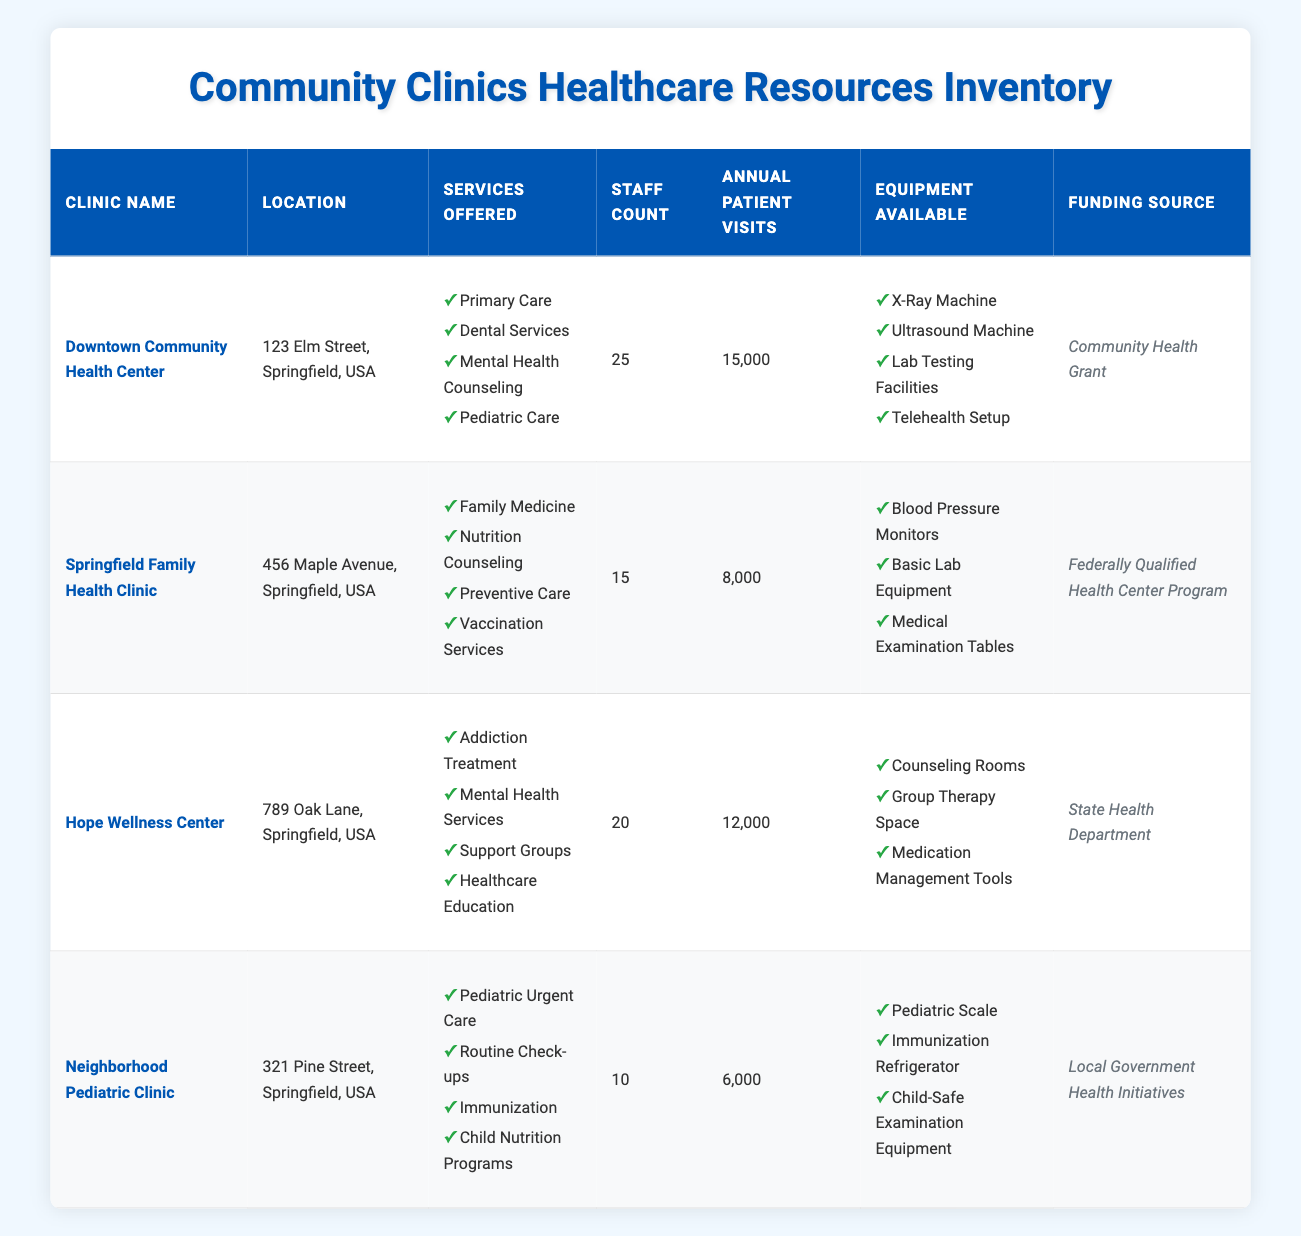What is the location of the Downtown Community Health Center? The Downtown Community Health Center is located at 123 Elm Street, Springfield, USA as specified in the table.
Answer: 123 Elm Street, Springfield, USA Which clinic offers Mental Health Counseling as a service? According to the services listed in the table, the Downtown Community Health Center provides Mental Health Counseling.
Answer: Downtown Community Health Center How many annual patient visits does the Springfield Family Health Clinic have compared to the Neighborhood Pediatric Clinic? The Springfield Family Health Clinic has 8,000 annual patient visits, while the Neighborhood Pediatric Clinic has 6,000. Therefore, the difference is 8,000 - 6,000 = 2,000 more visits for the Springfield Family Health Clinic.
Answer: 2,000 True or False: The Hope Wellness Center is funded by the Local Government Health Initiatives. The Hope Wellness Center's funding source is listed as being from the State Health Department, not the Local Government Health Initiatives, thus the statement is false.
Answer: False What is the total number of staff across all clinics? The staff counts for each clinic are: Downtown Community Health Center (25), Springfield Family Health Clinic (15), Hope Wellness Center (20), and Neighborhood Pediatric Clinic (10). Adding these together gives 25 + 15 + 20 + 10 = 70 staff members total.
Answer: 70 How many types of equipment are available at the Hope Wellness Center? The equipment list for the Hope Wellness Center includes Counseling Rooms, Group Therapy Space, and Medication Management Tools. This totals to three types of equipment available.
Answer: 3 Which clinic has the highest number of annual patient visits and what is that number? The Downtown Community Health Center has the highest annual patient visits listed at 15,000, more than any other clinic in the table.
Answer: 15,000 Is there any clinic offering Pediatric Care services? Yes, the Downtown Community Health Center offers Pediatric Care as one of its services provided. Hence, there is indeed a clinic that offers this service.
Answer: Yes Which clinic has the least annual patient visits and what is that number? The Neighborhood Pediatric Clinic has the least annual patient visits listed at 6,000 according to the table.
Answer: 6,000 